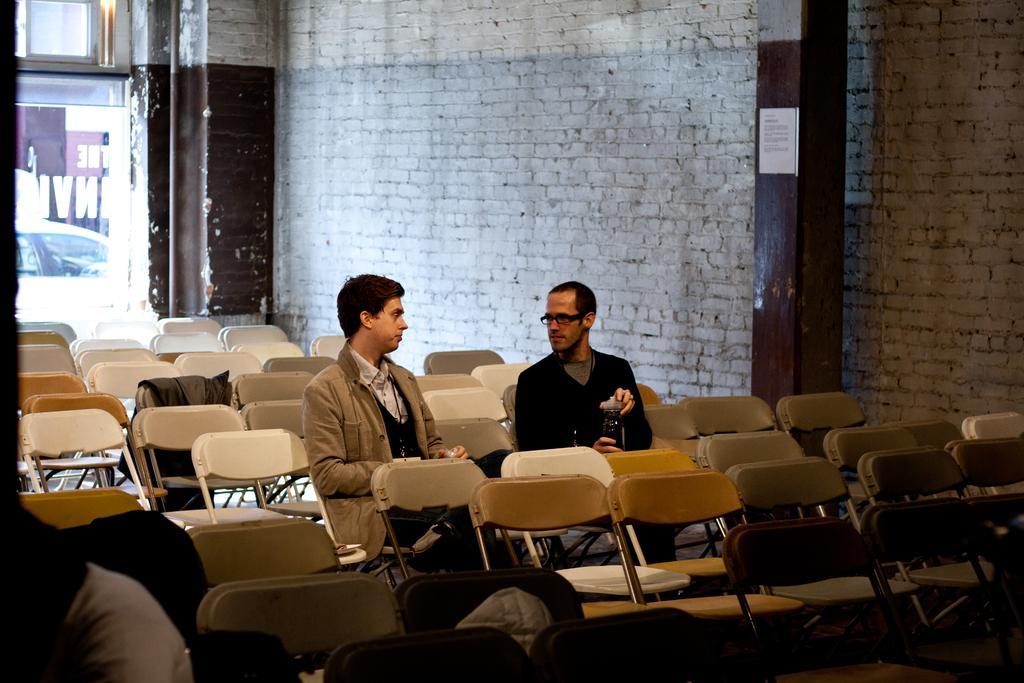Please provide a concise description of this image. In the image in the center we can see two persons were sitting on the chair and they were holding some objects. On the left side of the image we can see a person sitting and few backpacks on the chairs. And we can see one jacket and few empty chairs. In the background there is a brick wall,pillars,note and glass. Through glass,we can see a car. 